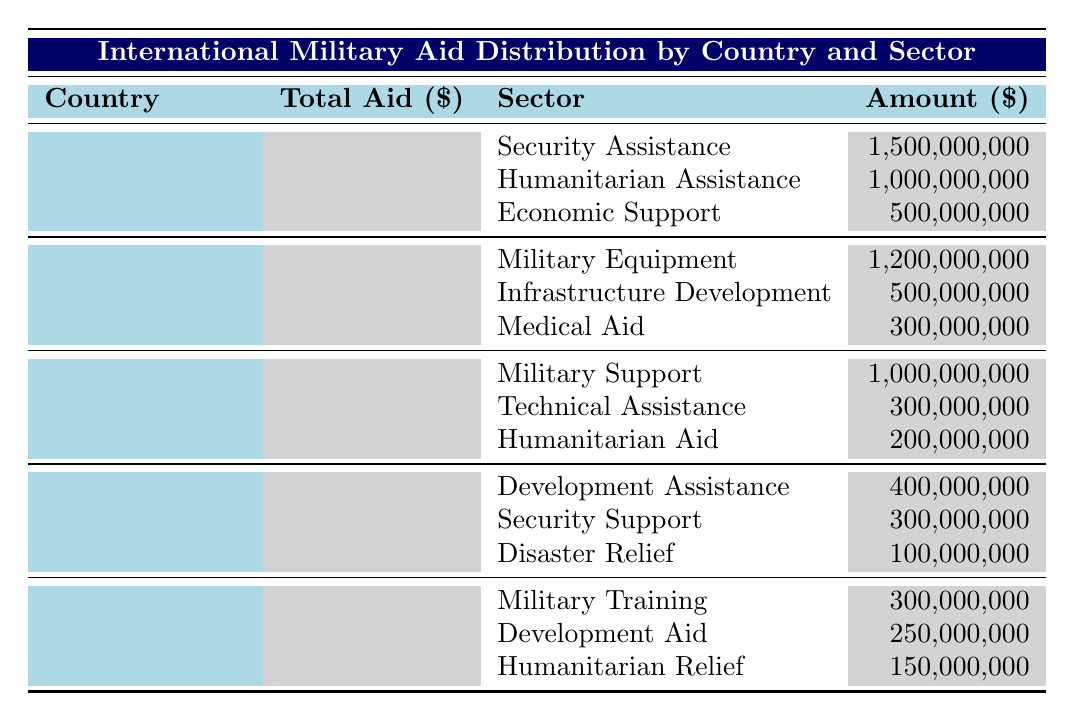What is the total amount of military aid provided by the United States? The table shows that the total aid from the United States is listed as 3,000,000,000.
Answer: 3,000,000,000 Which sector received the highest amount of aid from China? Looking at the sectors listed under China, "Military Equipment" received the highest amount at 1,200,000,000.
Answer: Military Equipment Is the total aid provided by Russia greater than that of Germany? By comparing the total aid values, Russia provided 1,500,000,000, while Germany provided 800,000,000. Since 1,500,000,000 is greater than 800,000,000, the statement is true.
Answer: Yes What is the sum of humanitarian assistance from the United States and humanitarian aid from Russia? From the United States, humanitarian assistance is 1,000,000,000, and for Russia, humanitarian aid is 200,000,000. Adding these amounts gives 1,000,000,000 + 200,000,000 = 1,200,000,000.
Answer: 1,200,000,000 What percentage of the total aid does Economic Support account for in the United States? To find the percentage, divide the Economic Support amount (500,000,000) by the total aid amount (3,000,000,000) and multiply by 100. The calculation is (500,000,000 / 3,000,000,000) * 100 = 16.67%.
Answer: 16.67% How much total aid did the United Kingdom distribute for military training? The table specifies that the United Kingdom distributed 300,000,000 for military training.
Answer: 300,000,000 Did Germany provide more aid in disaster relief than the United Kingdom provided in humanitarian relief? From the table, Germany's disaster relief is 100,000,000 and the United Kingdom's humanitarian relief is 150,000,000. Since 100,000,000 is less than 150,000,000, the statement is false.
Answer: No What is the combined total of Economic Support from the United States and Infrastructure Development from China? Economic Support from the United States is 500,000,000 and Infrastructure Development from China is 500,000,000. The combined total is 500,000,000 + 500,000,000 = 1,000,000,000.
Answer: 1,000,000,000 